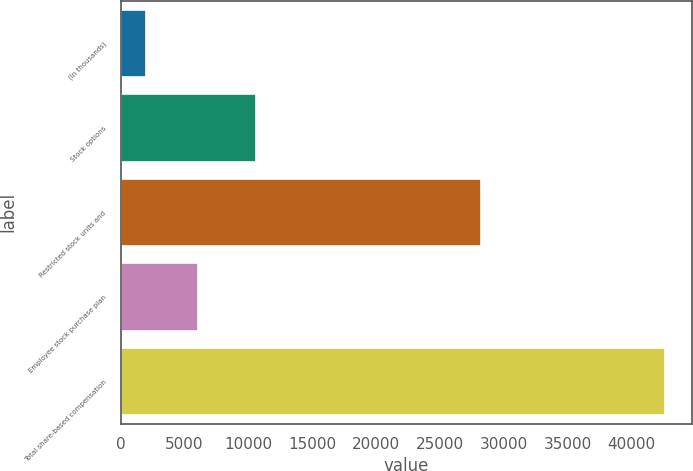<chart> <loc_0><loc_0><loc_500><loc_500><bar_chart><fcel>(In thousands)<fcel>Stock options<fcel>Restricted stock units and<fcel>Employee stock purchase plan<fcel>Total share-based compensation<nl><fcel>2013<fcel>10577<fcel>28229<fcel>6075.4<fcel>42637<nl></chart> 